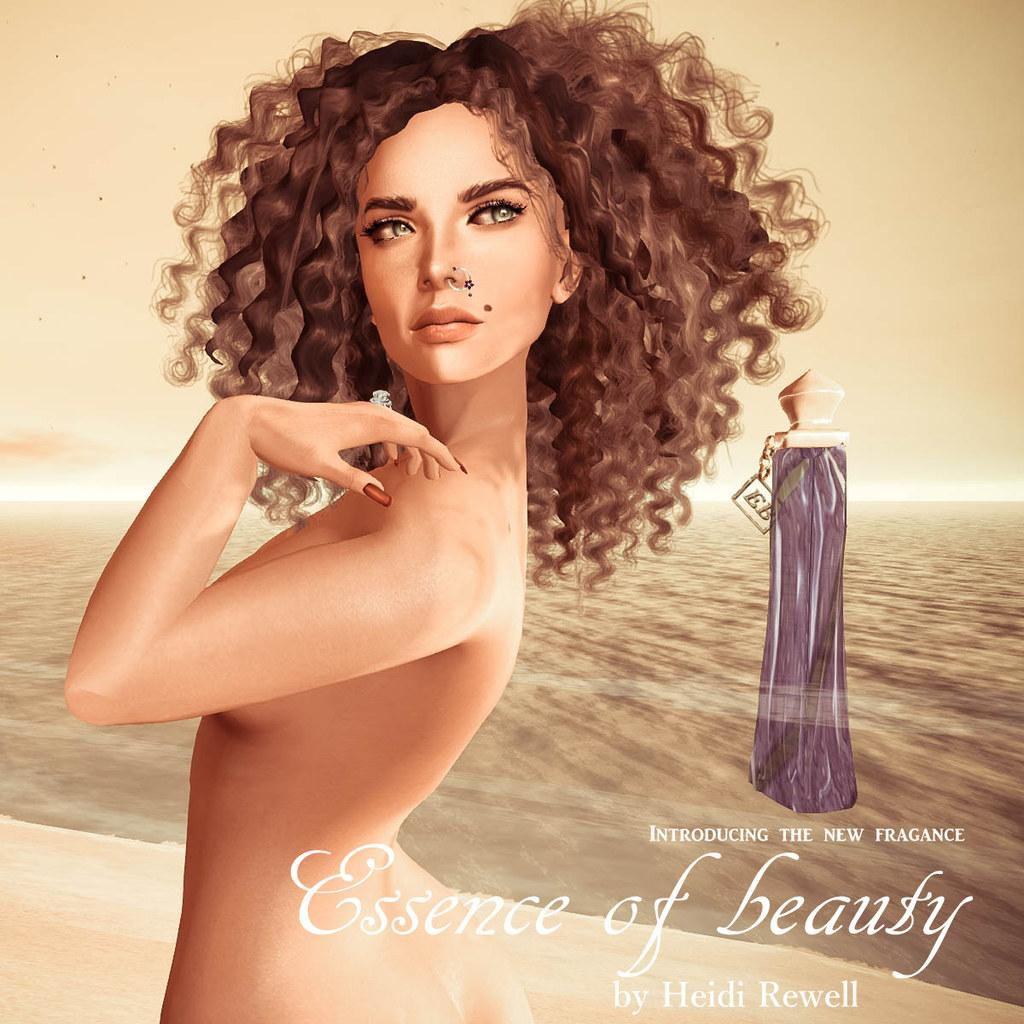<image>
Write a terse but informative summary of the picture. Women with frizzy hair posing next to a saying that says "Essence of Beauty". 